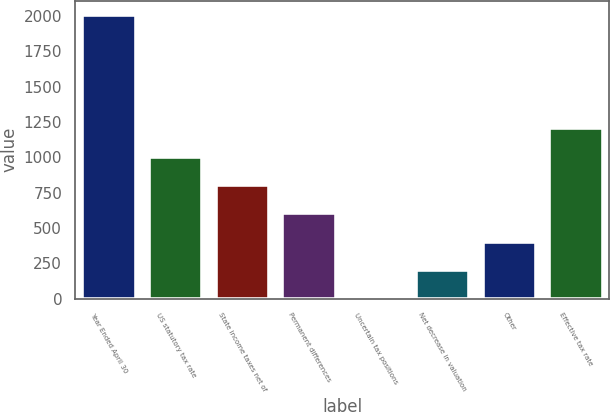Convert chart to OTSL. <chart><loc_0><loc_0><loc_500><loc_500><bar_chart><fcel>Year Ended April 30<fcel>US statutory tax rate<fcel>State income taxes net of<fcel>Permanent differences<fcel>Uncertain tax positions<fcel>Net decrease in valuation<fcel>Other<fcel>Effective tax rate<nl><fcel>2009<fcel>1004.75<fcel>803.9<fcel>603.05<fcel>0.5<fcel>201.35<fcel>402.2<fcel>1205.6<nl></chart> 